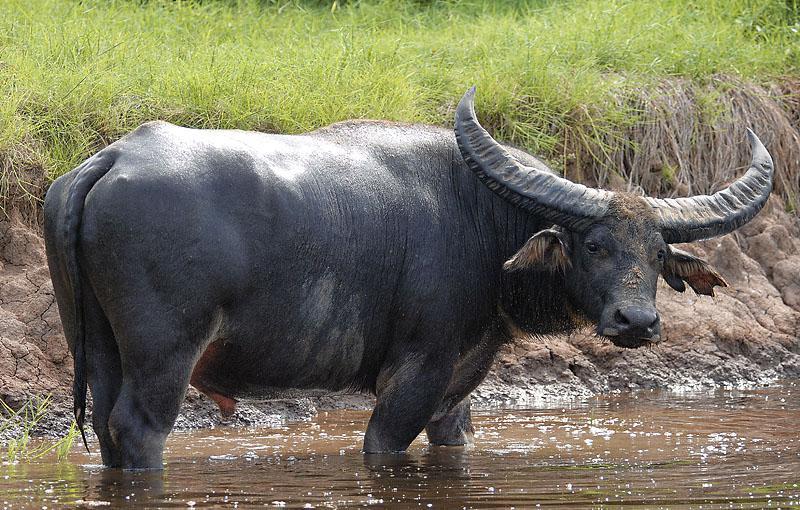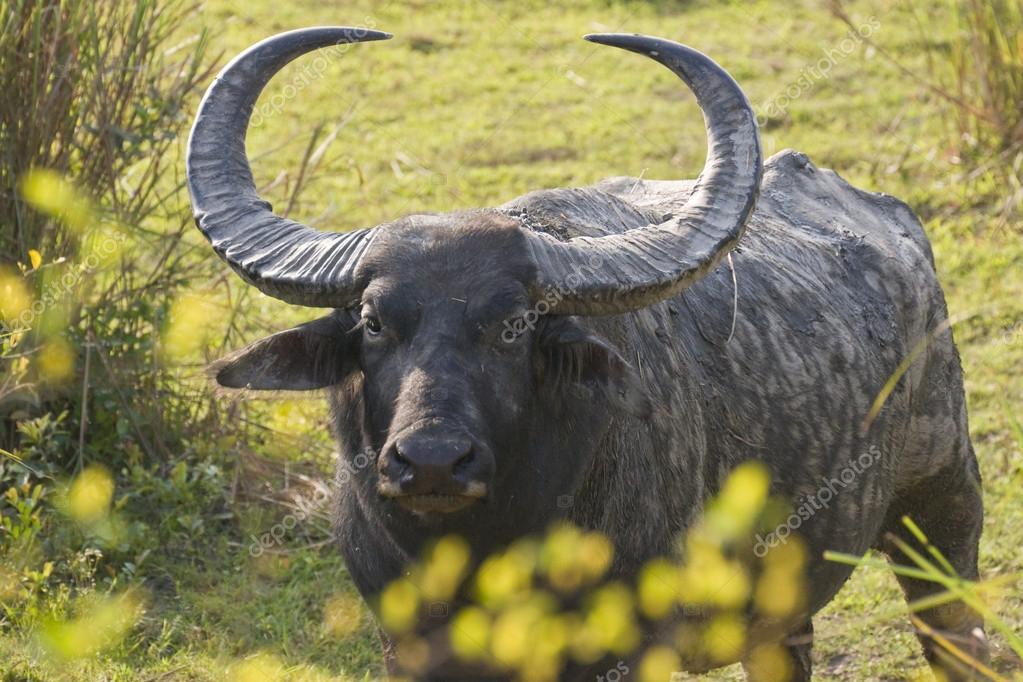The first image is the image on the left, the second image is the image on the right. Examine the images to the left and right. Is the description "The big horned cow on the left is brown and not black." accurate? Answer yes or no. No. The first image is the image on the left, the second image is the image on the right. Evaluate the accuracy of this statement regarding the images: "There are exactly two animals who are facing in the same direction.". Is it true? Answer yes or no. No. 